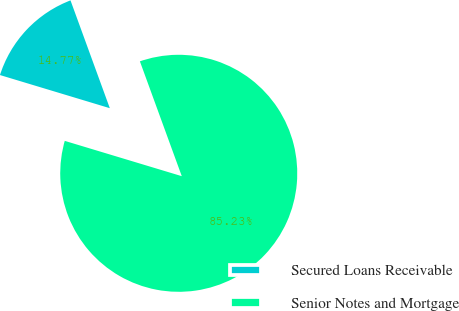Convert chart. <chart><loc_0><loc_0><loc_500><loc_500><pie_chart><fcel>Secured Loans Receivable<fcel>Senior Notes and Mortgage<nl><fcel>14.77%<fcel>85.23%<nl></chart> 